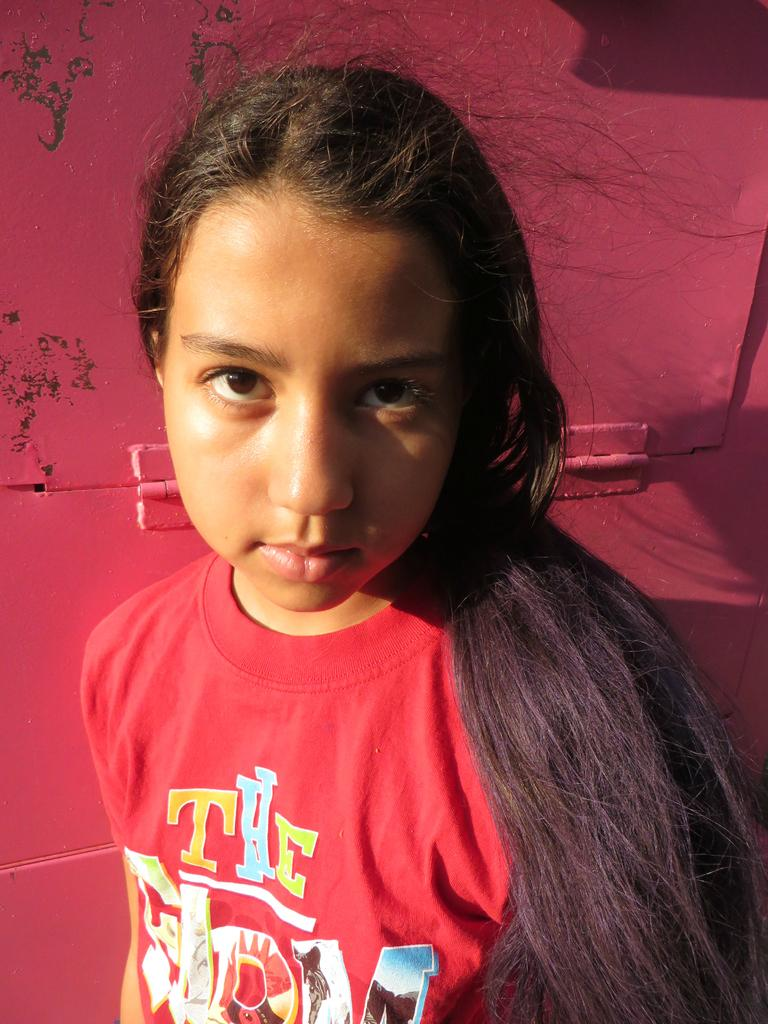<image>
Write a terse but informative summary of the picture. A girl wearing a The Farm t-shirt looks into the camera. 